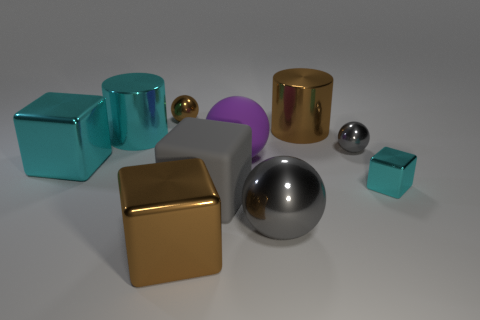Subtract 1 spheres. How many spheres are left? 3 Subtract all green blocks. Subtract all green balls. How many blocks are left? 4 Subtract all cylinders. How many objects are left? 8 Subtract 0 green blocks. How many objects are left? 10 Subtract all metallic spheres. Subtract all green rubber cubes. How many objects are left? 7 Add 7 purple matte things. How many purple matte things are left? 8 Add 8 small brown balls. How many small brown balls exist? 9 